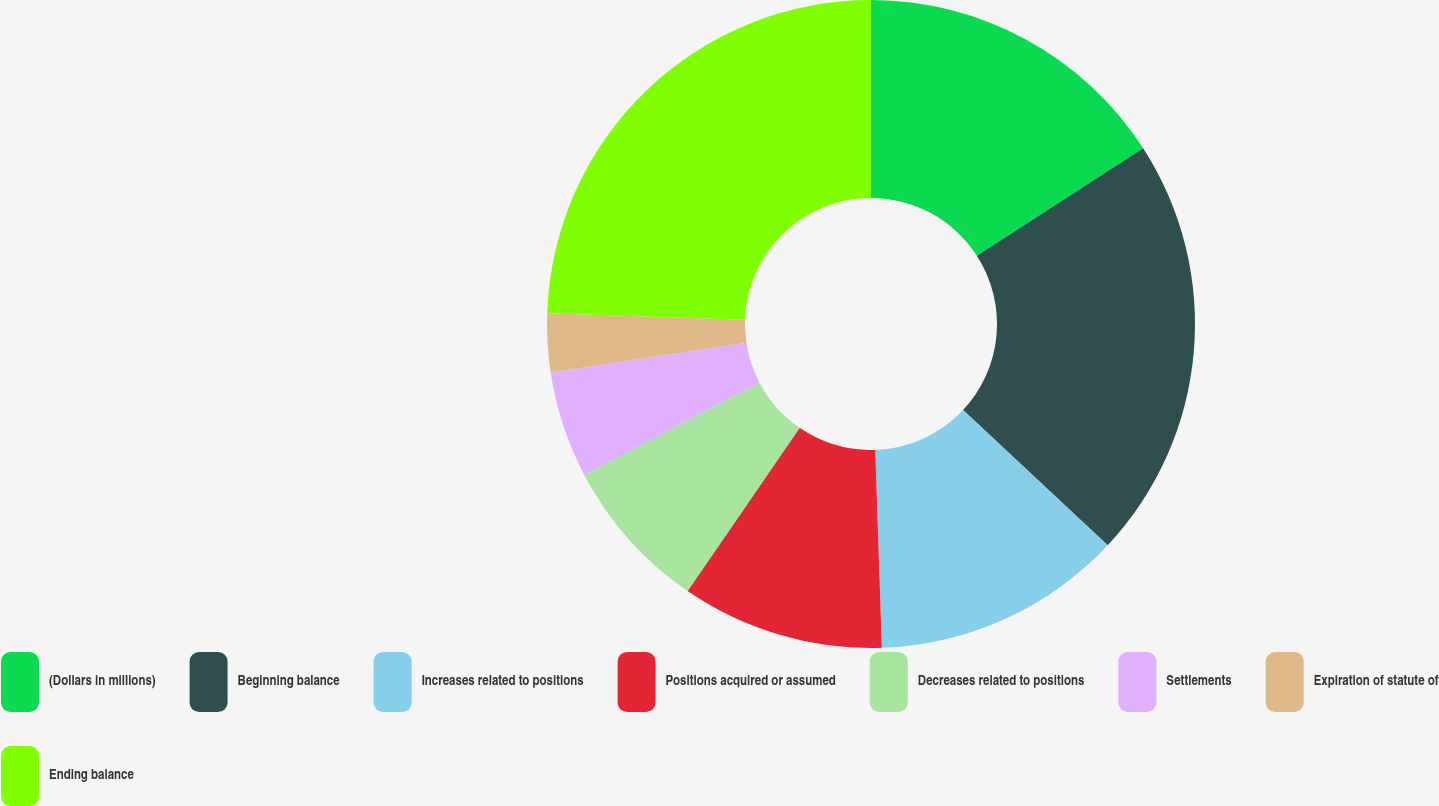<chart> <loc_0><loc_0><loc_500><loc_500><pie_chart><fcel>(Dollars in millions)<fcel>Beginning balance<fcel>Increases related to positions<fcel>Positions acquired or assumed<fcel>Decreases related to positions<fcel>Settlements<fcel>Expiration of statute of<fcel>Ending balance<nl><fcel>15.87%<fcel>21.09%<fcel>12.5%<fcel>10.11%<fcel>7.71%<fcel>5.32%<fcel>2.92%<fcel>24.47%<nl></chart> 